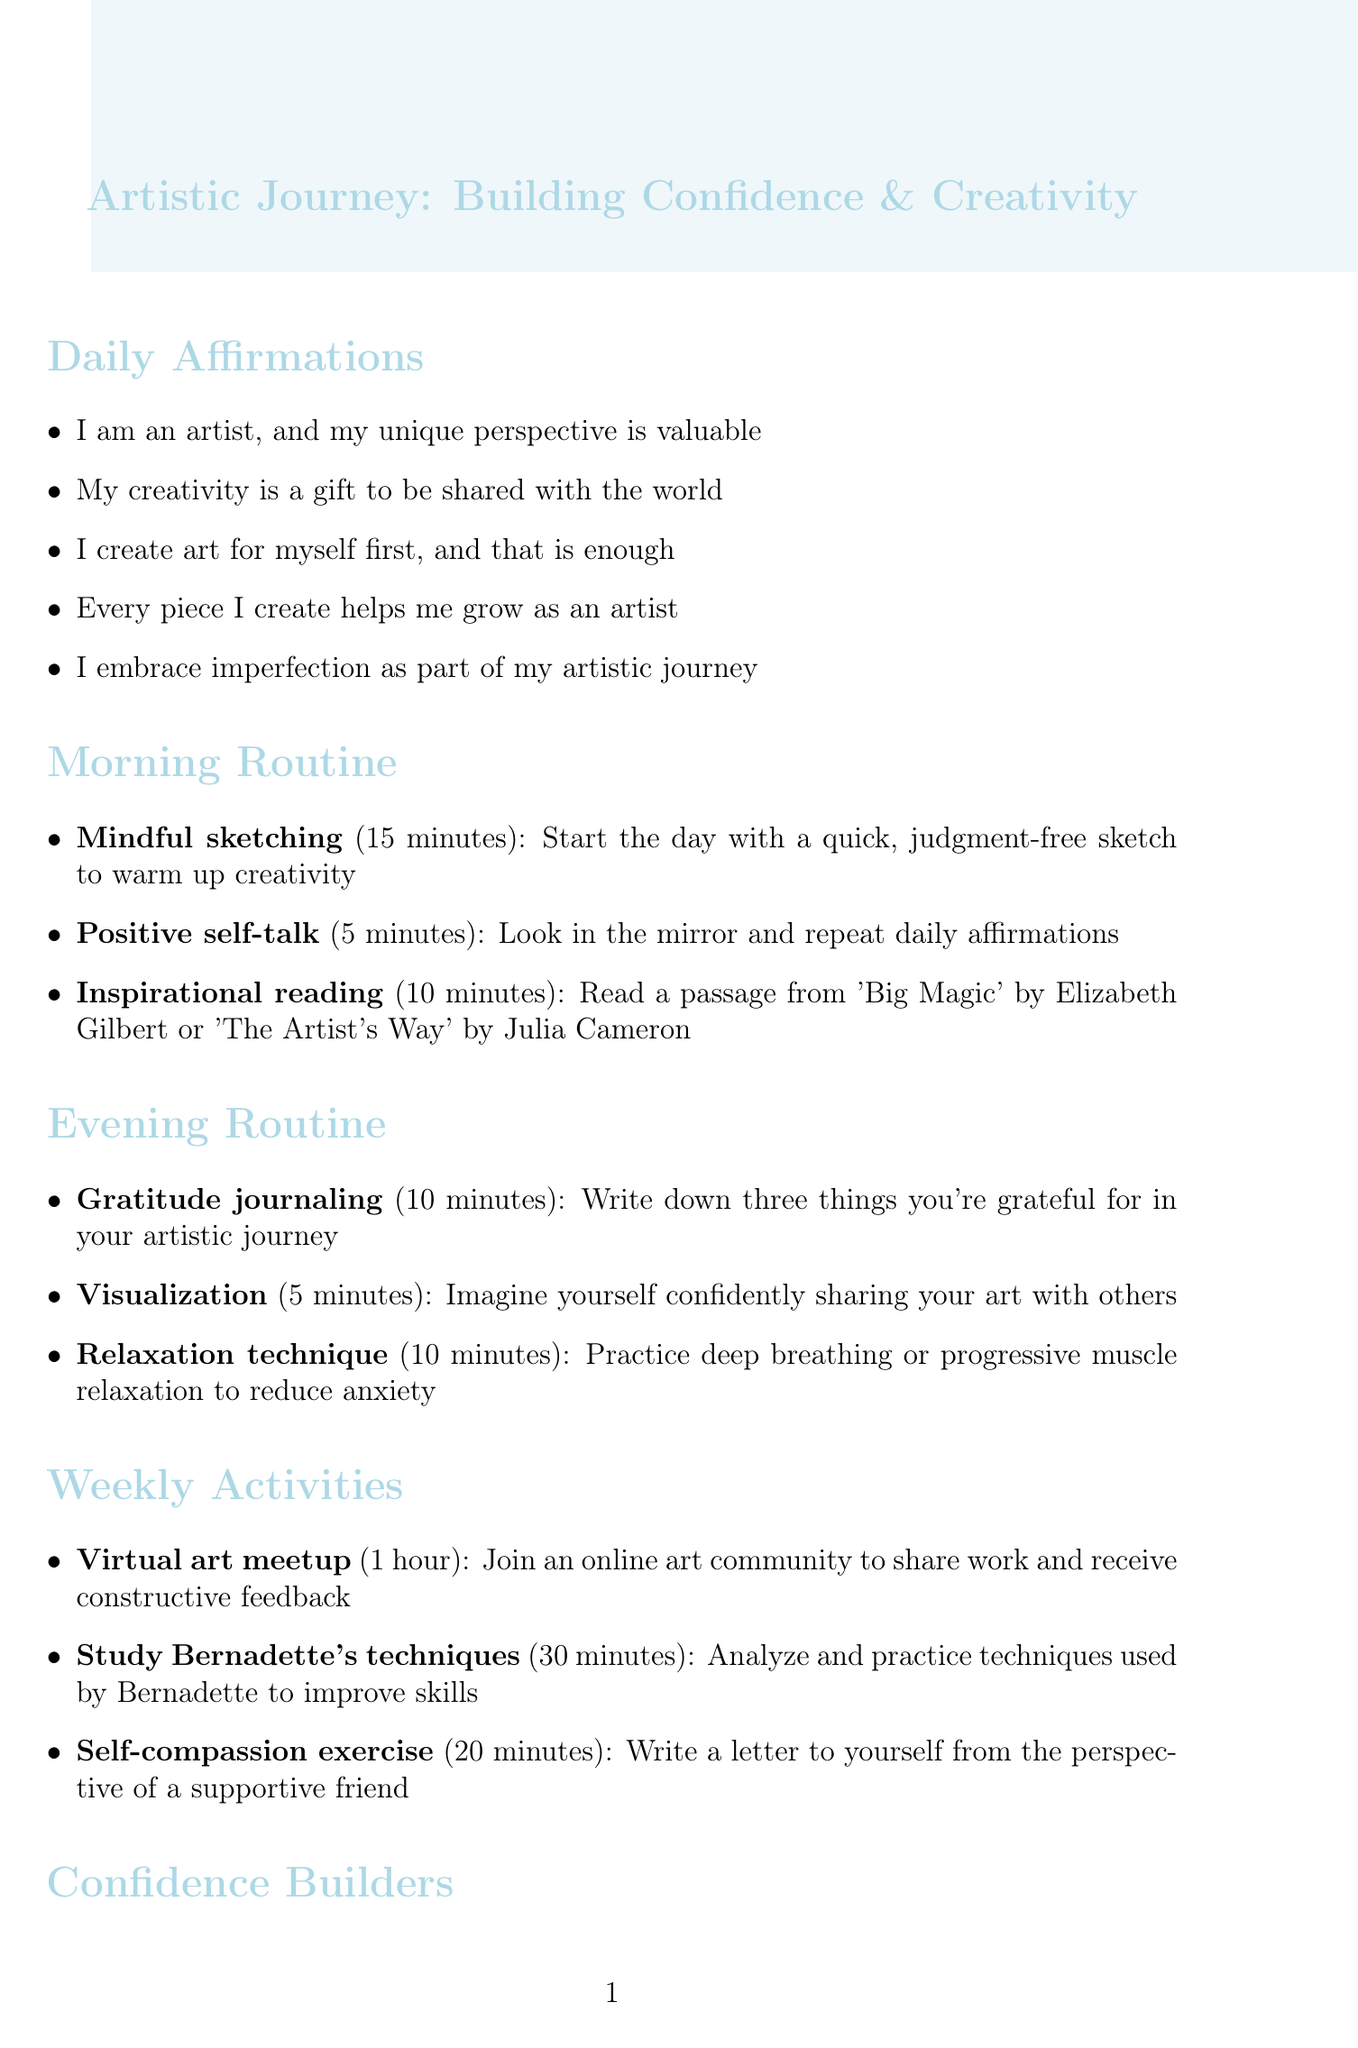What are the daily affirmations? The daily affirmations are a list of statements that help build confidence and reinforce the value of the artist's creativity.
Answer: I am an artist, and my unique perspective is valuable; My creativity is a gift to be shared with the world; I create art for myself first, and that is enough; Every piece I create helps me grow as an artist; I embrace imperfection as part of my artistic journey How long is the mindful sketching activity? The mindful sketching activity is part of the morning routine, lasting 15 minutes.
Answer: 15 minutes What is one confidence-building technique mentioned? A confidence-building technique is any method used to enhance self-esteem and reduce fear of criticism.
Answer: Exposure therapy What book is recommended for artistic growth? The document suggests resources for artistic growth, including books that provide insights into art making.
Answer: Art & Fear: Observations On the Perils (and Rewards) of Artmaking What is the total duration of the morning routine? The total duration combines the individual time commitments for each activity in the morning routine.
Answer: 30 minutes How many activities are in the weekly activities section? The weekly activities section lists specific tasks that help in improving artistic skills and confidence.
Answer: 3 activities What is the purpose of visualization in the evening routine? Visualization serves to build confidence by imagining oneself sharing art with others, reducing anxiety about criticism.
Answer: Imagine yourself confidently sharing your art with others What technique involves writing a supportive letter to oneself? This technique encourages self-acceptance and promotes positive self-reflection.
Answer: Self-compassion exercise 